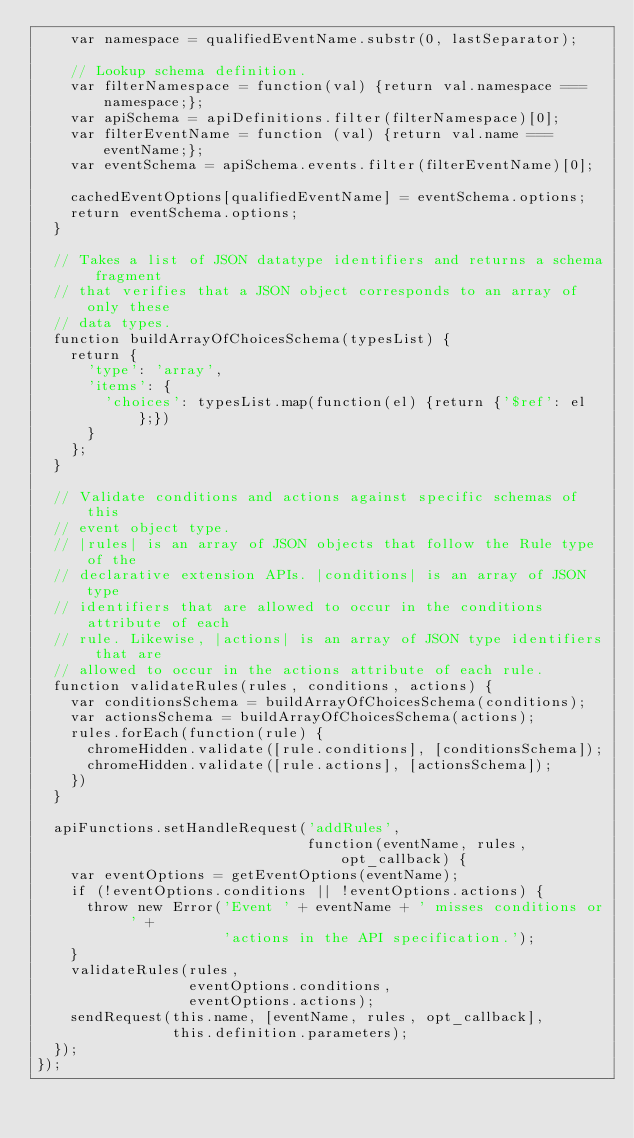<code> <loc_0><loc_0><loc_500><loc_500><_JavaScript_>    var namespace = qualifiedEventName.substr(0, lastSeparator);

    // Lookup schema definition.
    var filterNamespace = function(val) {return val.namespace === namespace;};
    var apiSchema = apiDefinitions.filter(filterNamespace)[0];
    var filterEventName = function (val) {return val.name === eventName;};
    var eventSchema = apiSchema.events.filter(filterEventName)[0];

    cachedEventOptions[qualifiedEventName] = eventSchema.options;
    return eventSchema.options;
  }

  // Takes a list of JSON datatype identifiers and returns a schema fragment
  // that verifies that a JSON object corresponds to an array of only these
  // data types.
  function buildArrayOfChoicesSchema(typesList) {
    return {
      'type': 'array',
      'items': {
        'choices': typesList.map(function(el) {return {'$ref': el};})
      }
    };
  }

  // Validate conditions and actions against specific schemas of this
  // event object type.
  // |rules| is an array of JSON objects that follow the Rule type of the
  // declarative extension APIs. |conditions| is an array of JSON type
  // identifiers that are allowed to occur in the conditions attribute of each
  // rule. Likewise, |actions| is an array of JSON type identifiers that are
  // allowed to occur in the actions attribute of each rule.
  function validateRules(rules, conditions, actions) {
    var conditionsSchema = buildArrayOfChoicesSchema(conditions);
    var actionsSchema = buildArrayOfChoicesSchema(actions);
    rules.forEach(function(rule) {
      chromeHidden.validate([rule.conditions], [conditionsSchema]);
      chromeHidden.validate([rule.actions], [actionsSchema]);
    })
  }

  apiFunctions.setHandleRequest('addRules',
                                function(eventName, rules, opt_callback) {
    var eventOptions = getEventOptions(eventName);
    if (!eventOptions.conditions || !eventOptions.actions) {
      throw new Error('Event ' + eventName + ' misses conditions or ' +
                      'actions in the API specification.');
    }
    validateRules(rules,
                  eventOptions.conditions,
                  eventOptions.actions);
    sendRequest(this.name, [eventName, rules, opt_callback],
                this.definition.parameters);
  });
});
</code> 